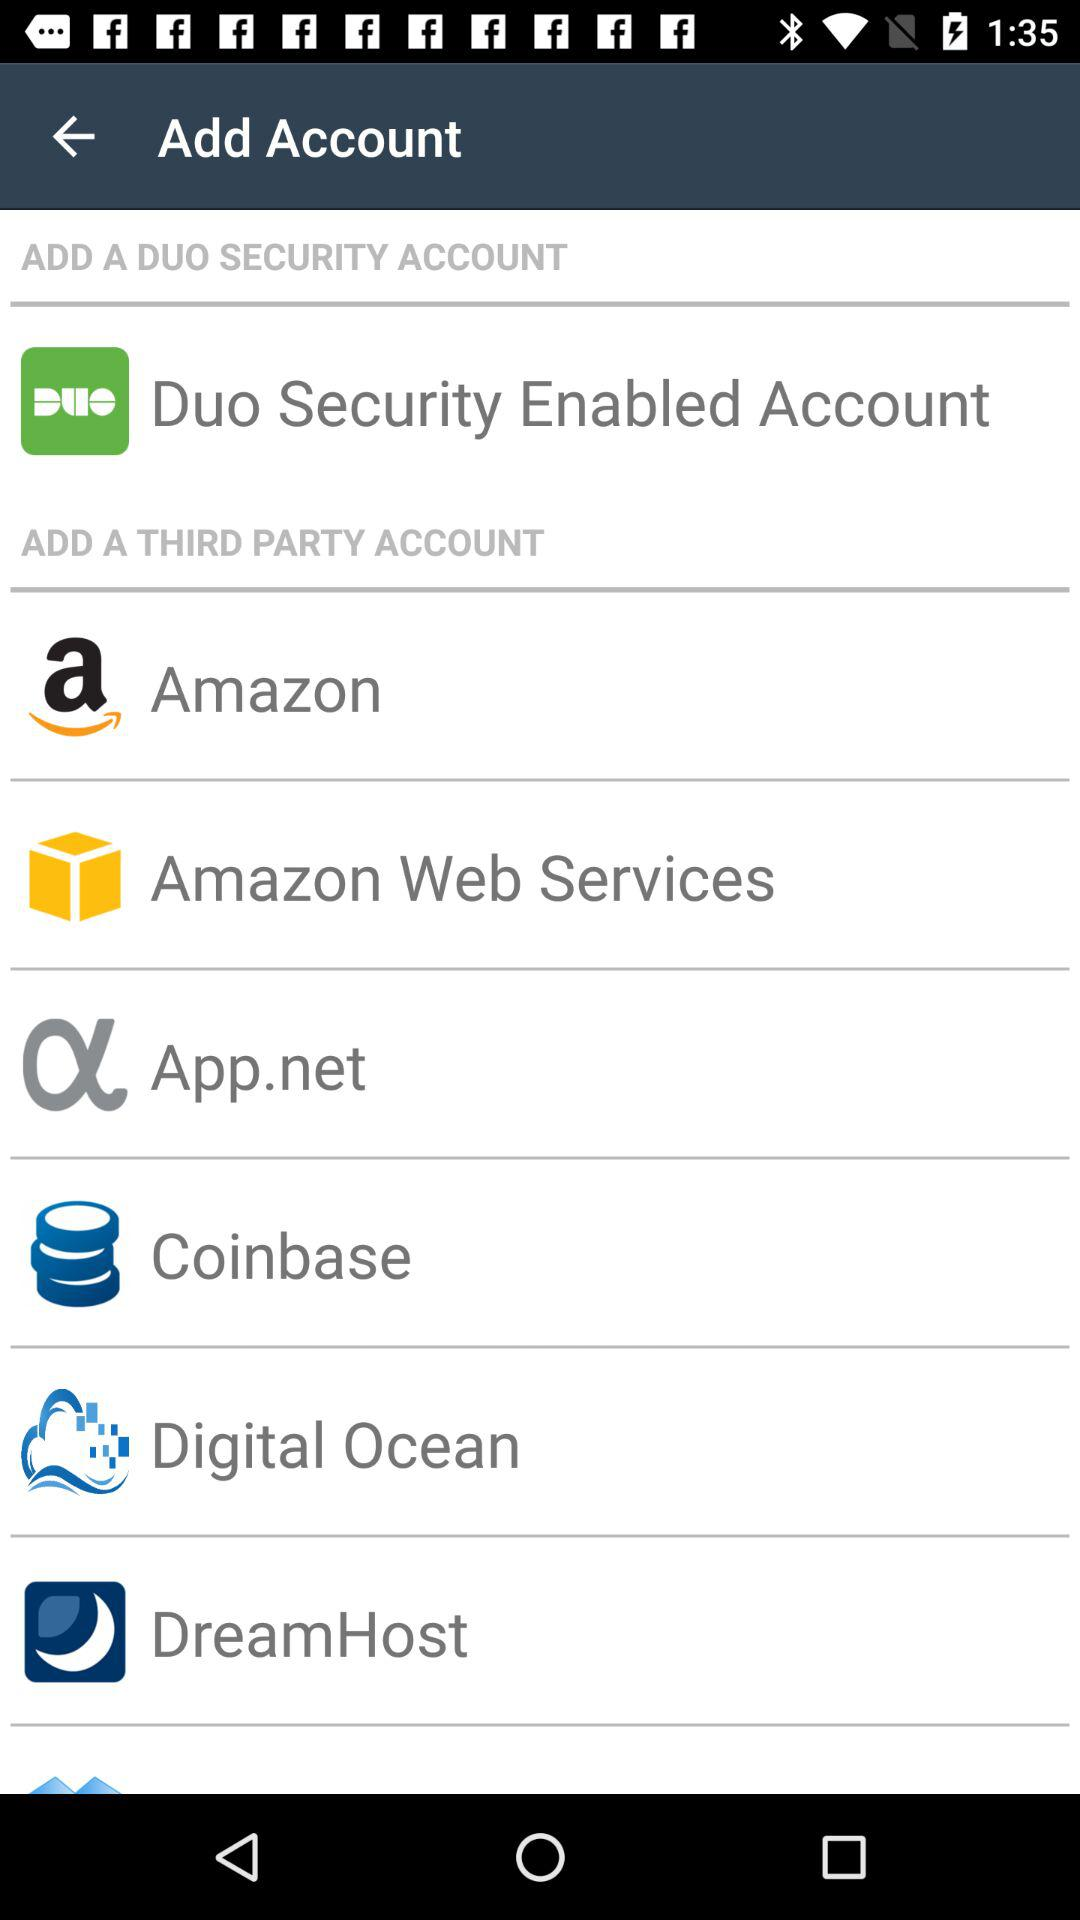How many third party accounts are available to add?
Answer the question using a single word or phrase. 6 